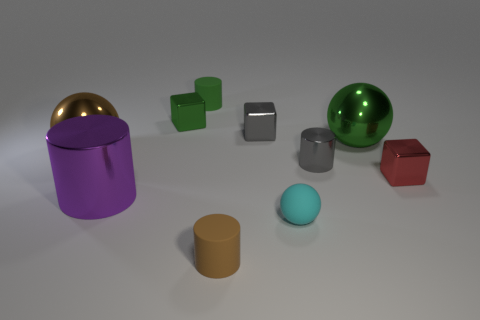Subtract 1 spheres. How many spheres are left? 2 Subtract all tiny gray cylinders. How many cylinders are left? 3 Subtract 1 cyan spheres. How many objects are left? 9 Subtract all spheres. How many objects are left? 7 Subtract all gray balls. Subtract all cyan blocks. How many balls are left? 3 Subtract all brown balls. How many green blocks are left? 1 Subtract all green metal objects. Subtract all purple cylinders. How many objects are left? 7 Add 7 big purple metal cylinders. How many big purple metal cylinders are left? 8 Add 6 big red rubber objects. How many big red rubber objects exist? 6 Subtract all green cubes. How many cubes are left? 2 